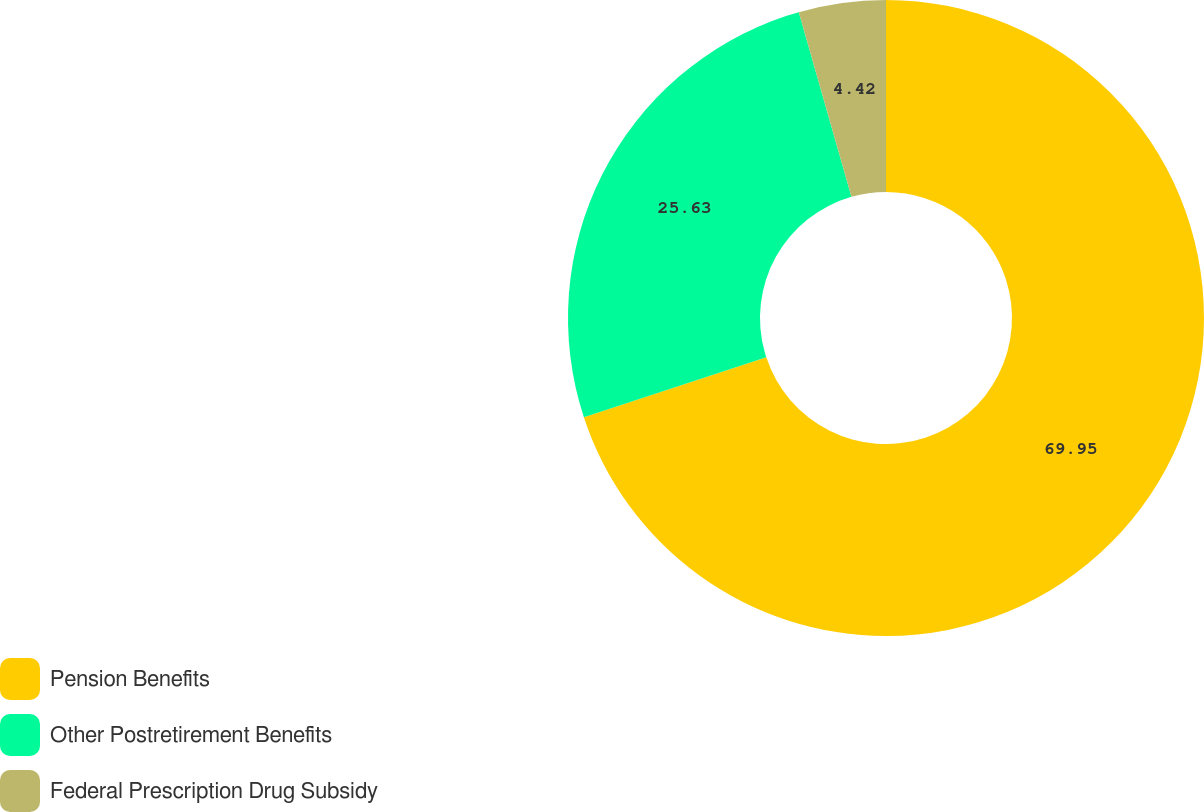Convert chart to OTSL. <chart><loc_0><loc_0><loc_500><loc_500><pie_chart><fcel>Pension Benefits<fcel>Other Postretirement Benefits<fcel>Federal Prescription Drug Subsidy<nl><fcel>69.95%<fcel>25.63%<fcel>4.42%<nl></chart> 